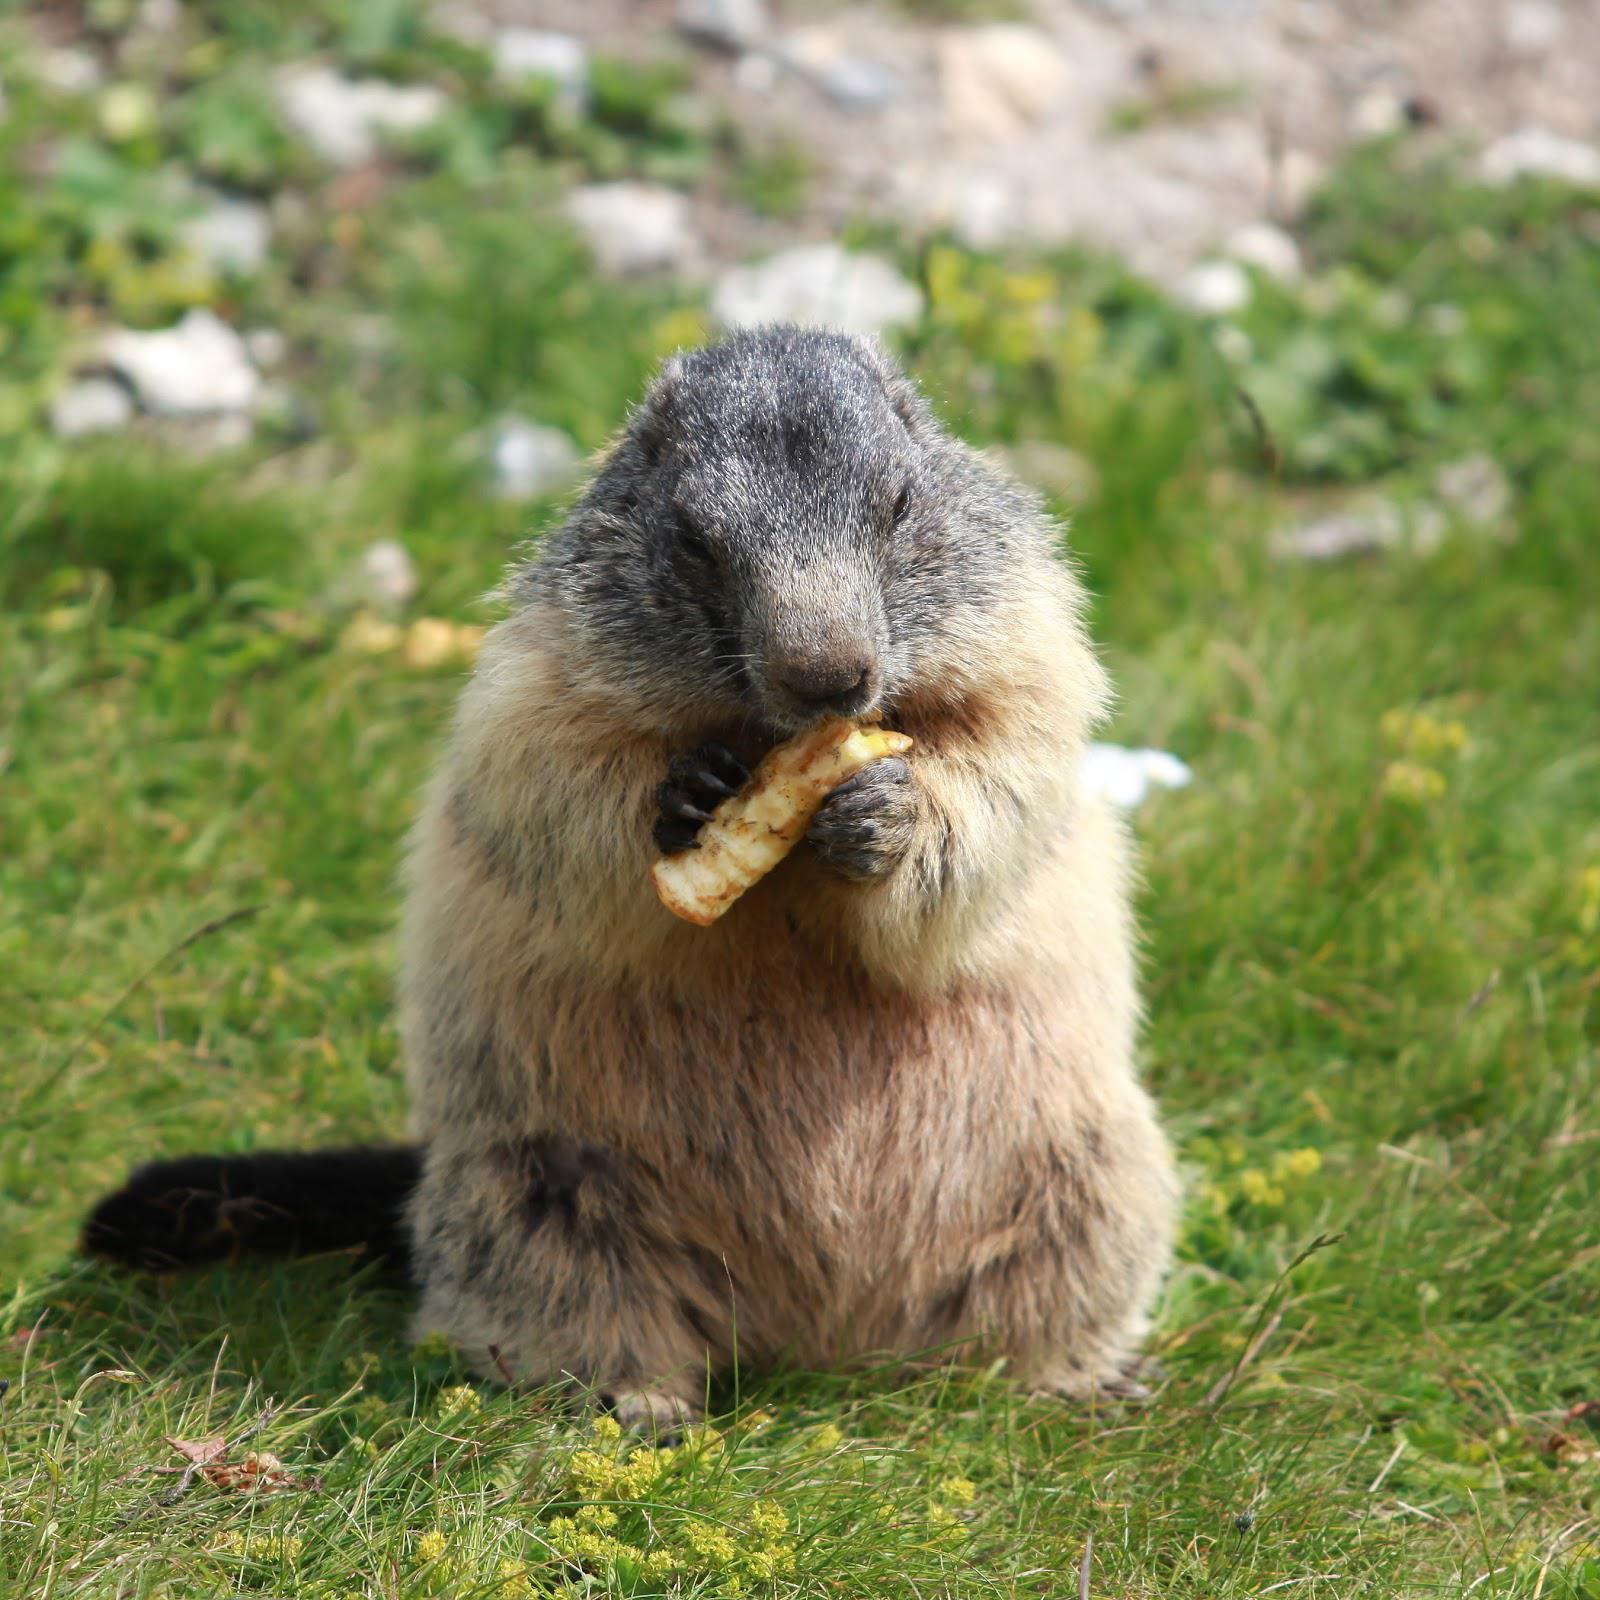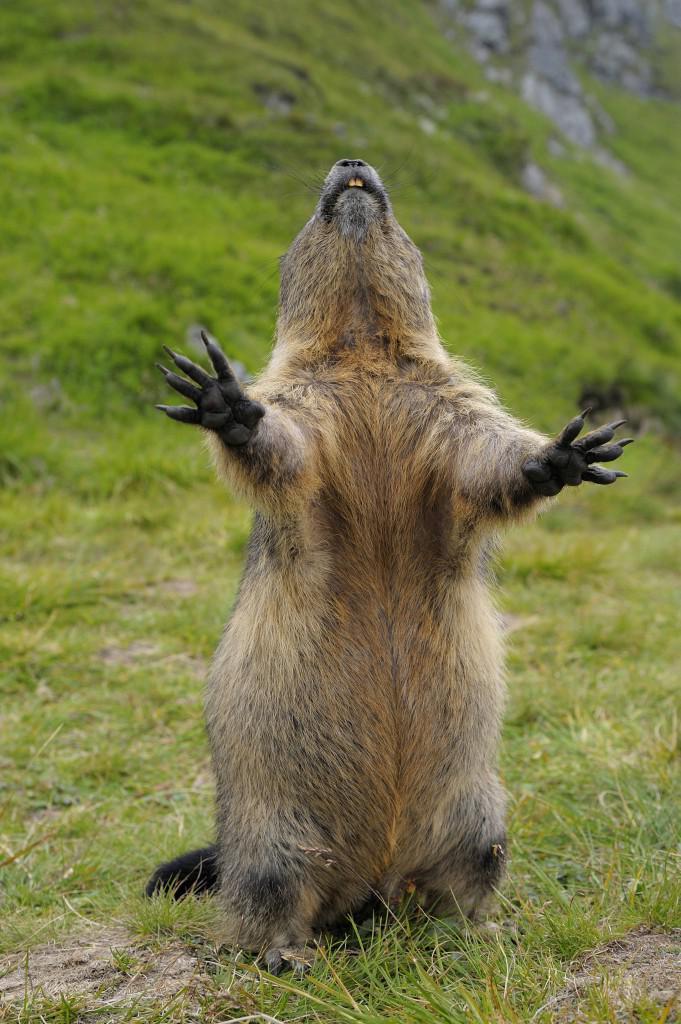The first image is the image on the left, the second image is the image on the right. Assess this claim about the two images: "the marmot is sitting in the grass eating". Correct or not? Answer yes or no. Yes. The first image is the image on the left, the second image is the image on the right. For the images shown, is this caption "The marmot on the left is eating something" true? Answer yes or no. Yes. 